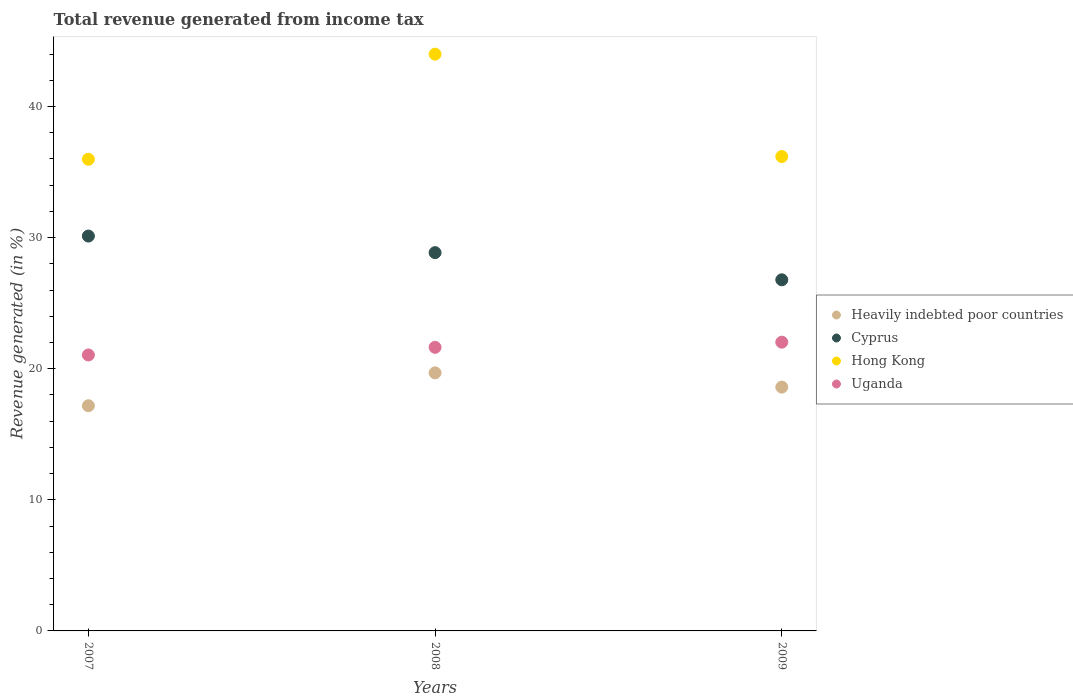What is the total revenue generated in Cyprus in 2008?
Keep it short and to the point. 28.86. Across all years, what is the maximum total revenue generated in Heavily indebted poor countries?
Provide a succinct answer. 19.69. Across all years, what is the minimum total revenue generated in Heavily indebted poor countries?
Your answer should be very brief. 17.18. In which year was the total revenue generated in Hong Kong maximum?
Keep it short and to the point. 2008. What is the total total revenue generated in Hong Kong in the graph?
Provide a short and direct response. 116.16. What is the difference between the total revenue generated in Hong Kong in 2007 and that in 2009?
Give a very brief answer. -0.21. What is the difference between the total revenue generated in Hong Kong in 2009 and the total revenue generated in Uganda in 2007?
Keep it short and to the point. 15.14. What is the average total revenue generated in Cyprus per year?
Ensure brevity in your answer.  28.59. In the year 2007, what is the difference between the total revenue generated in Uganda and total revenue generated in Heavily indebted poor countries?
Give a very brief answer. 3.87. What is the ratio of the total revenue generated in Heavily indebted poor countries in 2008 to that in 2009?
Your answer should be very brief. 1.06. Is the total revenue generated in Hong Kong in 2007 less than that in 2009?
Your answer should be compact. Yes. Is the difference between the total revenue generated in Uganda in 2007 and 2008 greater than the difference between the total revenue generated in Heavily indebted poor countries in 2007 and 2008?
Your answer should be compact. Yes. What is the difference between the highest and the second highest total revenue generated in Uganda?
Your answer should be very brief. 0.39. What is the difference between the highest and the lowest total revenue generated in Hong Kong?
Offer a terse response. 8.02. Is the sum of the total revenue generated in Hong Kong in 2007 and 2008 greater than the maximum total revenue generated in Cyprus across all years?
Ensure brevity in your answer.  Yes. Is it the case that in every year, the sum of the total revenue generated in Uganda and total revenue generated in Cyprus  is greater than the sum of total revenue generated in Heavily indebted poor countries and total revenue generated in Hong Kong?
Keep it short and to the point. Yes. Is the total revenue generated in Cyprus strictly greater than the total revenue generated in Heavily indebted poor countries over the years?
Your response must be concise. Yes. Is the total revenue generated in Cyprus strictly less than the total revenue generated in Hong Kong over the years?
Your answer should be compact. Yes. What is the difference between two consecutive major ticks on the Y-axis?
Keep it short and to the point. 10. Are the values on the major ticks of Y-axis written in scientific E-notation?
Offer a terse response. No. Does the graph contain any zero values?
Give a very brief answer. No. Does the graph contain grids?
Your answer should be very brief. No. Where does the legend appear in the graph?
Provide a succinct answer. Center right. How are the legend labels stacked?
Your answer should be very brief. Vertical. What is the title of the graph?
Provide a succinct answer. Total revenue generated from income tax. Does "Cote d'Ivoire" appear as one of the legend labels in the graph?
Offer a terse response. No. What is the label or title of the X-axis?
Provide a short and direct response. Years. What is the label or title of the Y-axis?
Offer a terse response. Revenue generated (in %). What is the Revenue generated (in %) of Heavily indebted poor countries in 2007?
Keep it short and to the point. 17.18. What is the Revenue generated (in %) in Cyprus in 2007?
Your response must be concise. 30.12. What is the Revenue generated (in %) of Hong Kong in 2007?
Offer a very short reply. 35.98. What is the Revenue generated (in %) of Uganda in 2007?
Make the answer very short. 21.05. What is the Revenue generated (in %) in Heavily indebted poor countries in 2008?
Keep it short and to the point. 19.69. What is the Revenue generated (in %) of Cyprus in 2008?
Ensure brevity in your answer.  28.86. What is the Revenue generated (in %) in Hong Kong in 2008?
Ensure brevity in your answer.  44. What is the Revenue generated (in %) of Uganda in 2008?
Keep it short and to the point. 21.63. What is the Revenue generated (in %) of Heavily indebted poor countries in 2009?
Your answer should be compact. 18.6. What is the Revenue generated (in %) of Cyprus in 2009?
Your answer should be compact. 26.78. What is the Revenue generated (in %) of Hong Kong in 2009?
Provide a short and direct response. 36.18. What is the Revenue generated (in %) of Uganda in 2009?
Give a very brief answer. 22.03. Across all years, what is the maximum Revenue generated (in %) in Heavily indebted poor countries?
Your response must be concise. 19.69. Across all years, what is the maximum Revenue generated (in %) of Cyprus?
Provide a succinct answer. 30.12. Across all years, what is the maximum Revenue generated (in %) of Hong Kong?
Your answer should be compact. 44. Across all years, what is the maximum Revenue generated (in %) in Uganda?
Your response must be concise. 22.03. Across all years, what is the minimum Revenue generated (in %) in Heavily indebted poor countries?
Keep it short and to the point. 17.18. Across all years, what is the minimum Revenue generated (in %) in Cyprus?
Give a very brief answer. 26.78. Across all years, what is the minimum Revenue generated (in %) of Hong Kong?
Make the answer very short. 35.98. Across all years, what is the minimum Revenue generated (in %) in Uganda?
Offer a terse response. 21.05. What is the total Revenue generated (in %) in Heavily indebted poor countries in the graph?
Offer a terse response. 55.46. What is the total Revenue generated (in %) of Cyprus in the graph?
Keep it short and to the point. 85.76. What is the total Revenue generated (in %) in Hong Kong in the graph?
Provide a short and direct response. 116.16. What is the total Revenue generated (in %) in Uganda in the graph?
Your answer should be very brief. 64.71. What is the difference between the Revenue generated (in %) in Heavily indebted poor countries in 2007 and that in 2008?
Provide a short and direct response. -2.51. What is the difference between the Revenue generated (in %) of Cyprus in 2007 and that in 2008?
Give a very brief answer. 1.27. What is the difference between the Revenue generated (in %) in Hong Kong in 2007 and that in 2008?
Make the answer very short. -8.02. What is the difference between the Revenue generated (in %) in Uganda in 2007 and that in 2008?
Ensure brevity in your answer.  -0.58. What is the difference between the Revenue generated (in %) of Heavily indebted poor countries in 2007 and that in 2009?
Ensure brevity in your answer.  -1.42. What is the difference between the Revenue generated (in %) in Cyprus in 2007 and that in 2009?
Your answer should be compact. 3.34. What is the difference between the Revenue generated (in %) in Hong Kong in 2007 and that in 2009?
Provide a succinct answer. -0.21. What is the difference between the Revenue generated (in %) of Uganda in 2007 and that in 2009?
Your answer should be compact. -0.98. What is the difference between the Revenue generated (in %) of Heavily indebted poor countries in 2008 and that in 2009?
Your answer should be compact. 1.09. What is the difference between the Revenue generated (in %) in Cyprus in 2008 and that in 2009?
Give a very brief answer. 2.07. What is the difference between the Revenue generated (in %) of Hong Kong in 2008 and that in 2009?
Give a very brief answer. 7.81. What is the difference between the Revenue generated (in %) of Uganda in 2008 and that in 2009?
Offer a very short reply. -0.39. What is the difference between the Revenue generated (in %) in Heavily indebted poor countries in 2007 and the Revenue generated (in %) in Cyprus in 2008?
Your response must be concise. -11.68. What is the difference between the Revenue generated (in %) in Heavily indebted poor countries in 2007 and the Revenue generated (in %) in Hong Kong in 2008?
Give a very brief answer. -26.82. What is the difference between the Revenue generated (in %) in Heavily indebted poor countries in 2007 and the Revenue generated (in %) in Uganda in 2008?
Provide a succinct answer. -4.46. What is the difference between the Revenue generated (in %) in Cyprus in 2007 and the Revenue generated (in %) in Hong Kong in 2008?
Make the answer very short. -13.88. What is the difference between the Revenue generated (in %) in Cyprus in 2007 and the Revenue generated (in %) in Uganda in 2008?
Make the answer very short. 8.49. What is the difference between the Revenue generated (in %) in Hong Kong in 2007 and the Revenue generated (in %) in Uganda in 2008?
Ensure brevity in your answer.  14.35. What is the difference between the Revenue generated (in %) of Heavily indebted poor countries in 2007 and the Revenue generated (in %) of Cyprus in 2009?
Offer a very short reply. -9.61. What is the difference between the Revenue generated (in %) in Heavily indebted poor countries in 2007 and the Revenue generated (in %) in Hong Kong in 2009?
Ensure brevity in your answer.  -19.01. What is the difference between the Revenue generated (in %) in Heavily indebted poor countries in 2007 and the Revenue generated (in %) in Uganda in 2009?
Keep it short and to the point. -4.85. What is the difference between the Revenue generated (in %) of Cyprus in 2007 and the Revenue generated (in %) of Hong Kong in 2009?
Give a very brief answer. -6.06. What is the difference between the Revenue generated (in %) of Cyprus in 2007 and the Revenue generated (in %) of Uganda in 2009?
Offer a very short reply. 8.1. What is the difference between the Revenue generated (in %) of Hong Kong in 2007 and the Revenue generated (in %) of Uganda in 2009?
Provide a short and direct response. 13.95. What is the difference between the Revenue generated (in %) of Heavily indebted poor countries in 2008 and the Revenue generated (in %) of Cyprus in 2009?
Provide a succinct answer. -7.1. What is the difference between the Revenue generated (in %) in Heavily indebted poor countries in 2008 and the Revenue generated (in %) in Hong Kong in 2009?
Offer a very short reply. -16.5. What is the difference between the Revenue generated (in %) in Heavily indebted poor countries in 2008 and the Revenue generated (in %) in Uganda in 2009?
Offer a very short reply. -2.34. What is the difference between the Revenue generated (in %) of Cyprus in 2008 and the Revenue generated (in %) of Hong Kong in 2009?
Your answer should be compact. -7.33. What is the difference between the Revenue generated (in %) of Cyprus in 2008 and the Revenue generated (in %) of Uganda in 2009?
Make the answer very short. 6.83. What is the difference between the Revenue generated (in %) of Hong Kong in 2008 and the Revenue generated (in %) of Uganda in 2009?
Make the answer very short. 21.97. What is the average Revenue generated (in %) of Heavily indebted poor countries per year?
Give a very brief answer. 18.49. What is the average Revenue generated (in %) in Cyprus per year?
Offer a very short reply. 28.59. What is the average Revenue generated (in %) in Hong Kong per year?
Offer a very short reply. 38.72. What is the average Revenue generated (in %) in Uganda per year?
Offer a very short reply. 21.57. In the year 2007, what is the difference between the Revenue generated (in %) in Heavily indebted poor countries and Revenue generated (in %) in Cyprus?
Offer a terse response. -12.94. In the year 2007, what is the difference between the Revenue generated (in %) of Heavily indebted poor countries and Revenue generated (in %) of Hong Kong?
Provide a short and direct response. -18.8. In the year 2007, what is the difference between the Revenue generated (in %) in Heavily indebted poor countries and Revenue generated (in %) in Uganda?
Keep it short and to the point. -3.87. In the year 2007, what is the difference between the Revenue generated (in %) of Cyprus and Revenue generated (in %) of Hong Kong?
Provide a short and direct response. -5.86. In the year 2007, what is the difference between the Revenue generated (in %) of Cyprus and Revenue generated (in %) of Uganda?
Keep it short and to the point. 9.07. In the year 2007, what is the difference between the Revenue generated (in %) in Hong Kong and Revenue generated (in %) in Uganda?
Make the answer very short. 14.93. In the year 2008, what is the difference between the Revenue generated (in %) of Heavily indebted poor countries and Revenue generated (in %) of Cyprus?
Provide a succinct answer. -9.17. In the year 2008, what is the difference between the Revenue generated (in %) in Heavily indebted poor countries and Revenue generated (in %) in Hong Kong?
Offer a very short reply. -24.31. In the year 2008, what is the difference between the Revenue generated (in %) in Heavily indebted poor countries and Revenue generated (in %) in Uganda?
Your response must be concise. -1.95. In the year 2008, what is the difference between the Revenue generated (in %) in Cyprus and Revenue generated (in %) in Hong Kong?
Your answer should be compact. -15.14. In the year 2008, what is the difference between the Revenue generated (in %) of Cyprus and Revenue generated (in %) of Uganda?
Provide a short and direct response. 7.22. In the year 2008, what is the difference between the Revenue generated (in %) in Hong Kong and Revenue generated (in %) in Uganda?
Make the answer very short. 22.36. In the year 2009, what is the difference between the Revenue generated (in %) in Heavily indebted poor countries and Revenue generated (in %) in Cyprus?
Your response must be concise. -8.18. In the year 2009, what is the difference between the Revenue generated (in %) in Heavily indebted poor countries and Revenue generated (in %) in Hong Kong?
Your answer should be compact. -17.59. In the year 2009, what is the difference between the Revenue generated (in %) in Heavily indebted poor countries and Revenue generated (in %) in Uganda?
Provide a succinct answer. -3.43. In the year 2009, what is the difference between the Revenue generated (in %) of Cyprus and Revenue generated (in %) of Hong Kong?
Offer a terse response. -9.4. In the year 2009, what is the difference between the Revenue generated (in %) of Cyprus and Revenue generated (in %) of Uganda?
Ensure brevity in your answer.  4.76. In the year 2009, what is the difference between the Revenue generated (in %) of Hong Kong and Revenue generated (in %) of Uganda?
Give a very brief answer. 14.16. What is the ratio of the Revenue generated (in %) of Heavily indebted poor countries in 2007 to that in 2008?
Your answer should be very brief. 0.87. What is the ratio of the Revenue generated (in %) of Cyprus in 2007 to that in 2008?
Your response must be concise. 1.04. What is the ratio of the Revenue generated (in %) of Hong Kong in 2007 to that in 2008?
Provide a succinct answer. 0.82. What is the ratio of the Revenue generated (in %) of Heavily indebted poor countries in 2007 to that in 2009?
Your answer should be compact. 0.92. What is the ratio of the Revenue generated (in %) in Cyprus in 2007 to that in 2009?
Provide a short and direct response. 1.12. What is the ratio of the Revenue generated (in %) in Uganda in 2007 to that in 2009?
Provide a short and direct response. 0.96. What is the ratio of the Revenue generated (in %) of Heavily indebted poor countries in 2008 to that in 2009?
Give a very brief answer. 1.06. What is the ratio of the Revenue generated (in %) of Cyprus in 2008 to that in 2009?
Offer a terse response. 1.08. What is the ratio of the Revenue generated (in %) in Hong Kong in 2008 to that in 2009?
Provide a short and direct response. 1.22. What is the ratio of the Revenue generated (in %) of Uganda in 2008 to that in 2009?
Your response must be concise. 0.98. What is the difference between the highest and the second highest Revenue generated (in %) of Heavily indebted poor countries?
Give a very brief answer. 1.09. What is the difference between the highest and the second highest Revenue generated (in %) in Cyprus?
Your answer should be very brief. 1.27. What is the difference between the highest and the second highest Revenue generated (in %) of Hong Kong?
Your answer should be very brief. 7.81. What is the difference between the highest and the second highest Revenue generated (in %) in Uganda?
Provide a short and direct response. 0.39. What is the difference between the highest and the lowest Revenue generated (in %) in Heavily indebted poor countries?
Provide a short and direct response. 2.51. What is the difference between the highest and the lowest Revenue generated (in %) in Cyprus?
Keep it short and to the point. 3.34. What is the difference between the highest and the lowest Revenue generated (in %) in Hong Kong?
Keep it short and to the point. 8.02. What is the difference between the highest and the lowest Revenue generated (in %) of Uganda?
Give a very brief answer. 0.98. 